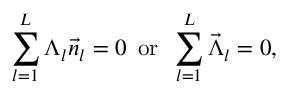<formula> <loc_0><loc_0><loc_500><loc_500>\sum _ { l = 1 } ^ { L } \Lambda _ { l } \vec { n } _ { l } = 0 \, o r \, \sum _ { l = 1 } ^ { L } \vec { \Lambda } _ { l } = 0 ,</formula> 